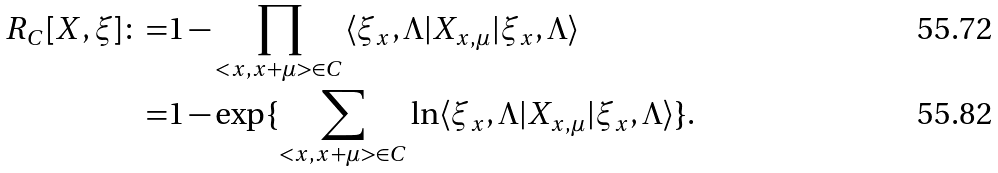<formula> <loc_0><loc_0><loc_500><loc_500>R _ { C } [ X , \xi ] \colon = & 1 - \prod _ { < x , x + \mu > \in C } \langle \xi _ { x } , \Lambda | X _ { x , \mu } | \xi _ { x } , \Lambda \rangle \\ = & 1 - \exp \{ \sum _ { < x , x + \mu > \in C } \ln \langle \xi _ { x } , \Lambda | X _ { x , \mu } | \xi _ { x } , \Lambda \rangle \} .</formula> 